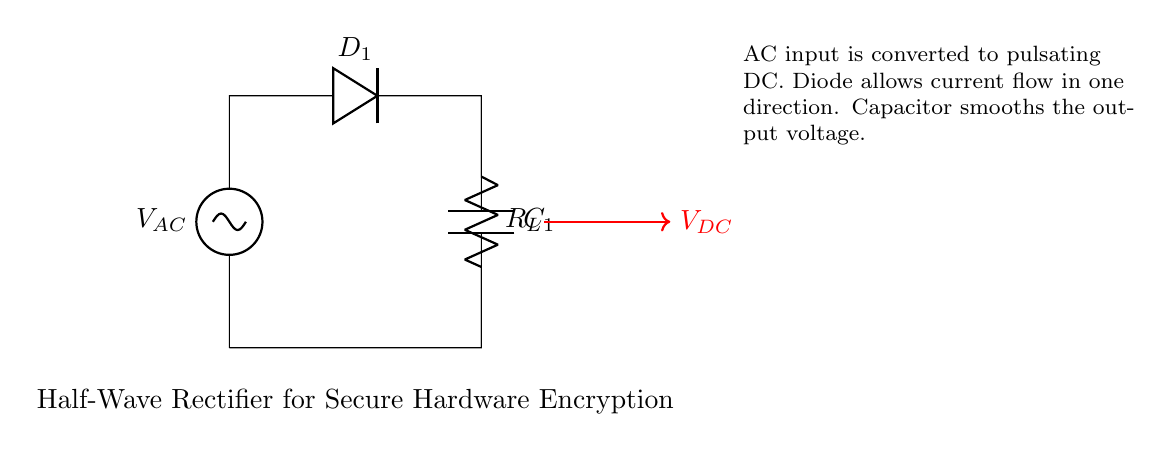What is the type of rectifier used in this circuit? The circuit is labeled as a "Half-Wave Rectifier," which indicates that it only allows one half of the AC waveform to pass through while blocking the other half.
Answer: Half-Wave Rectifier What component smooths the output voltage in the circuit? The capacitor labeled as "C1" is connected in parallel to the load resistor and is responsible for smoothing the pulsating DC output voltage from the rectifier.
Answer: C1 What does the diode in this circuit do? The diode labeled as "D1" allows current to flow in one direction only, which converts the AC input into a pulsating DC signal by blocking the negative half-cycle of the AC waveform.
Answer: Allows current flow in one direction What is the purpose of the load resistor in this circuit? The load resistor labeled as "R_L" is used to provide a load to the circuit, thus allowing for the conversion of electrical energy into a useful form, such as powering a device.
Answer: Provide a load What happens to the AC waveform after it passes through the diode? After passing through the diode, the AC waveform is converted into a pulsating DC signal, which represents the positive half-cycles of the original AC input voltage.
Answer: Pulsating DC How many components are actively involved in rectifying the AC input? Only two components are actively involved in rectifying the AC input: the diode "D1," which rectifies the AC, and the capacitor "C1," which smooths the output DC.
Answer: Two components 